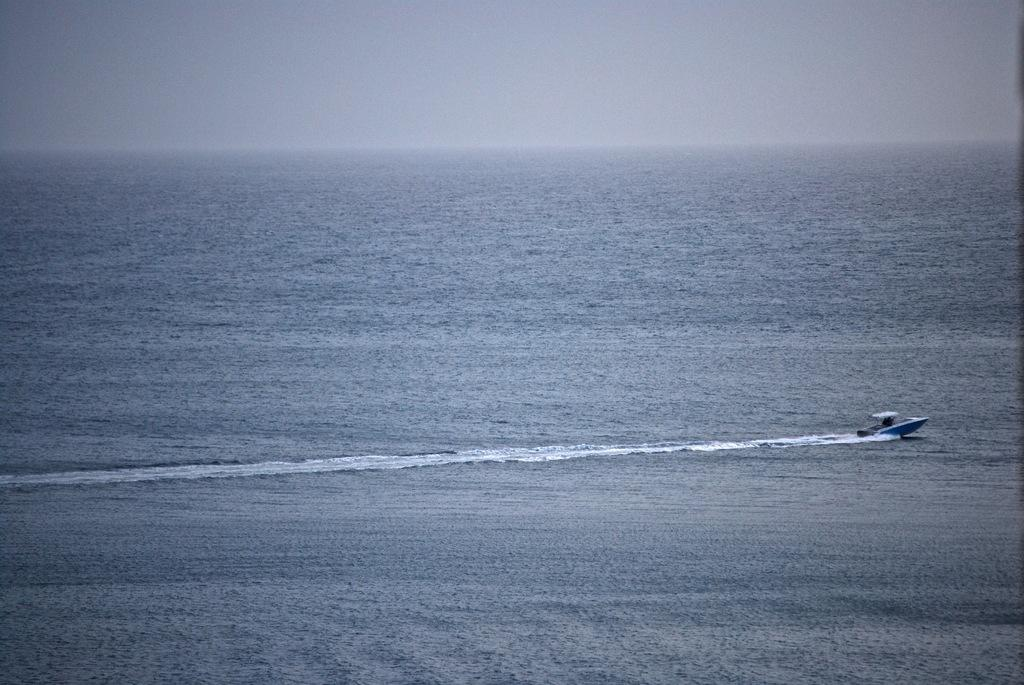Where was the picture taken? The picture was clicked outside the city. What can be seen in the image besides the landscape? There is a water body and a jet ski-like object in the water body. What is visible in the background of the image? The sky is visible in the background of the image. What type of bat is flying in the image? There is no bat present in the image. Who is the governor in the image? There is no governor present in the image. 